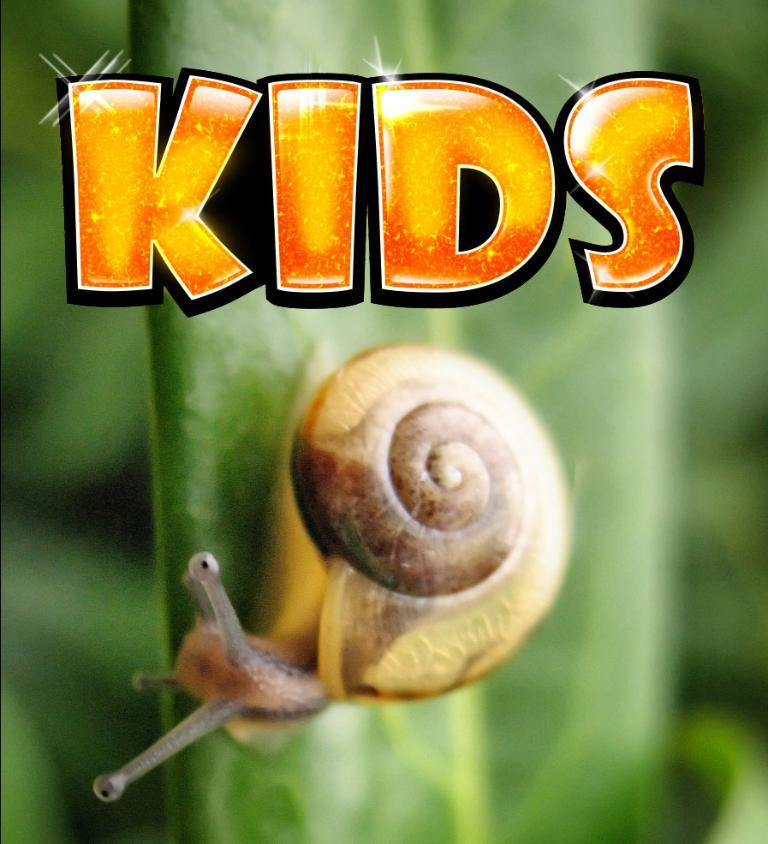What is the main subject in the center of the image? There is a snail in the center of the image. What can be seen at the top of the image? There is text at the top of the image. How would you describe the background of the image? The background of the image is blurred. What is the tendency of the clock in the image? There is no clock present in the image, so it's not possible to determine its tendency. 